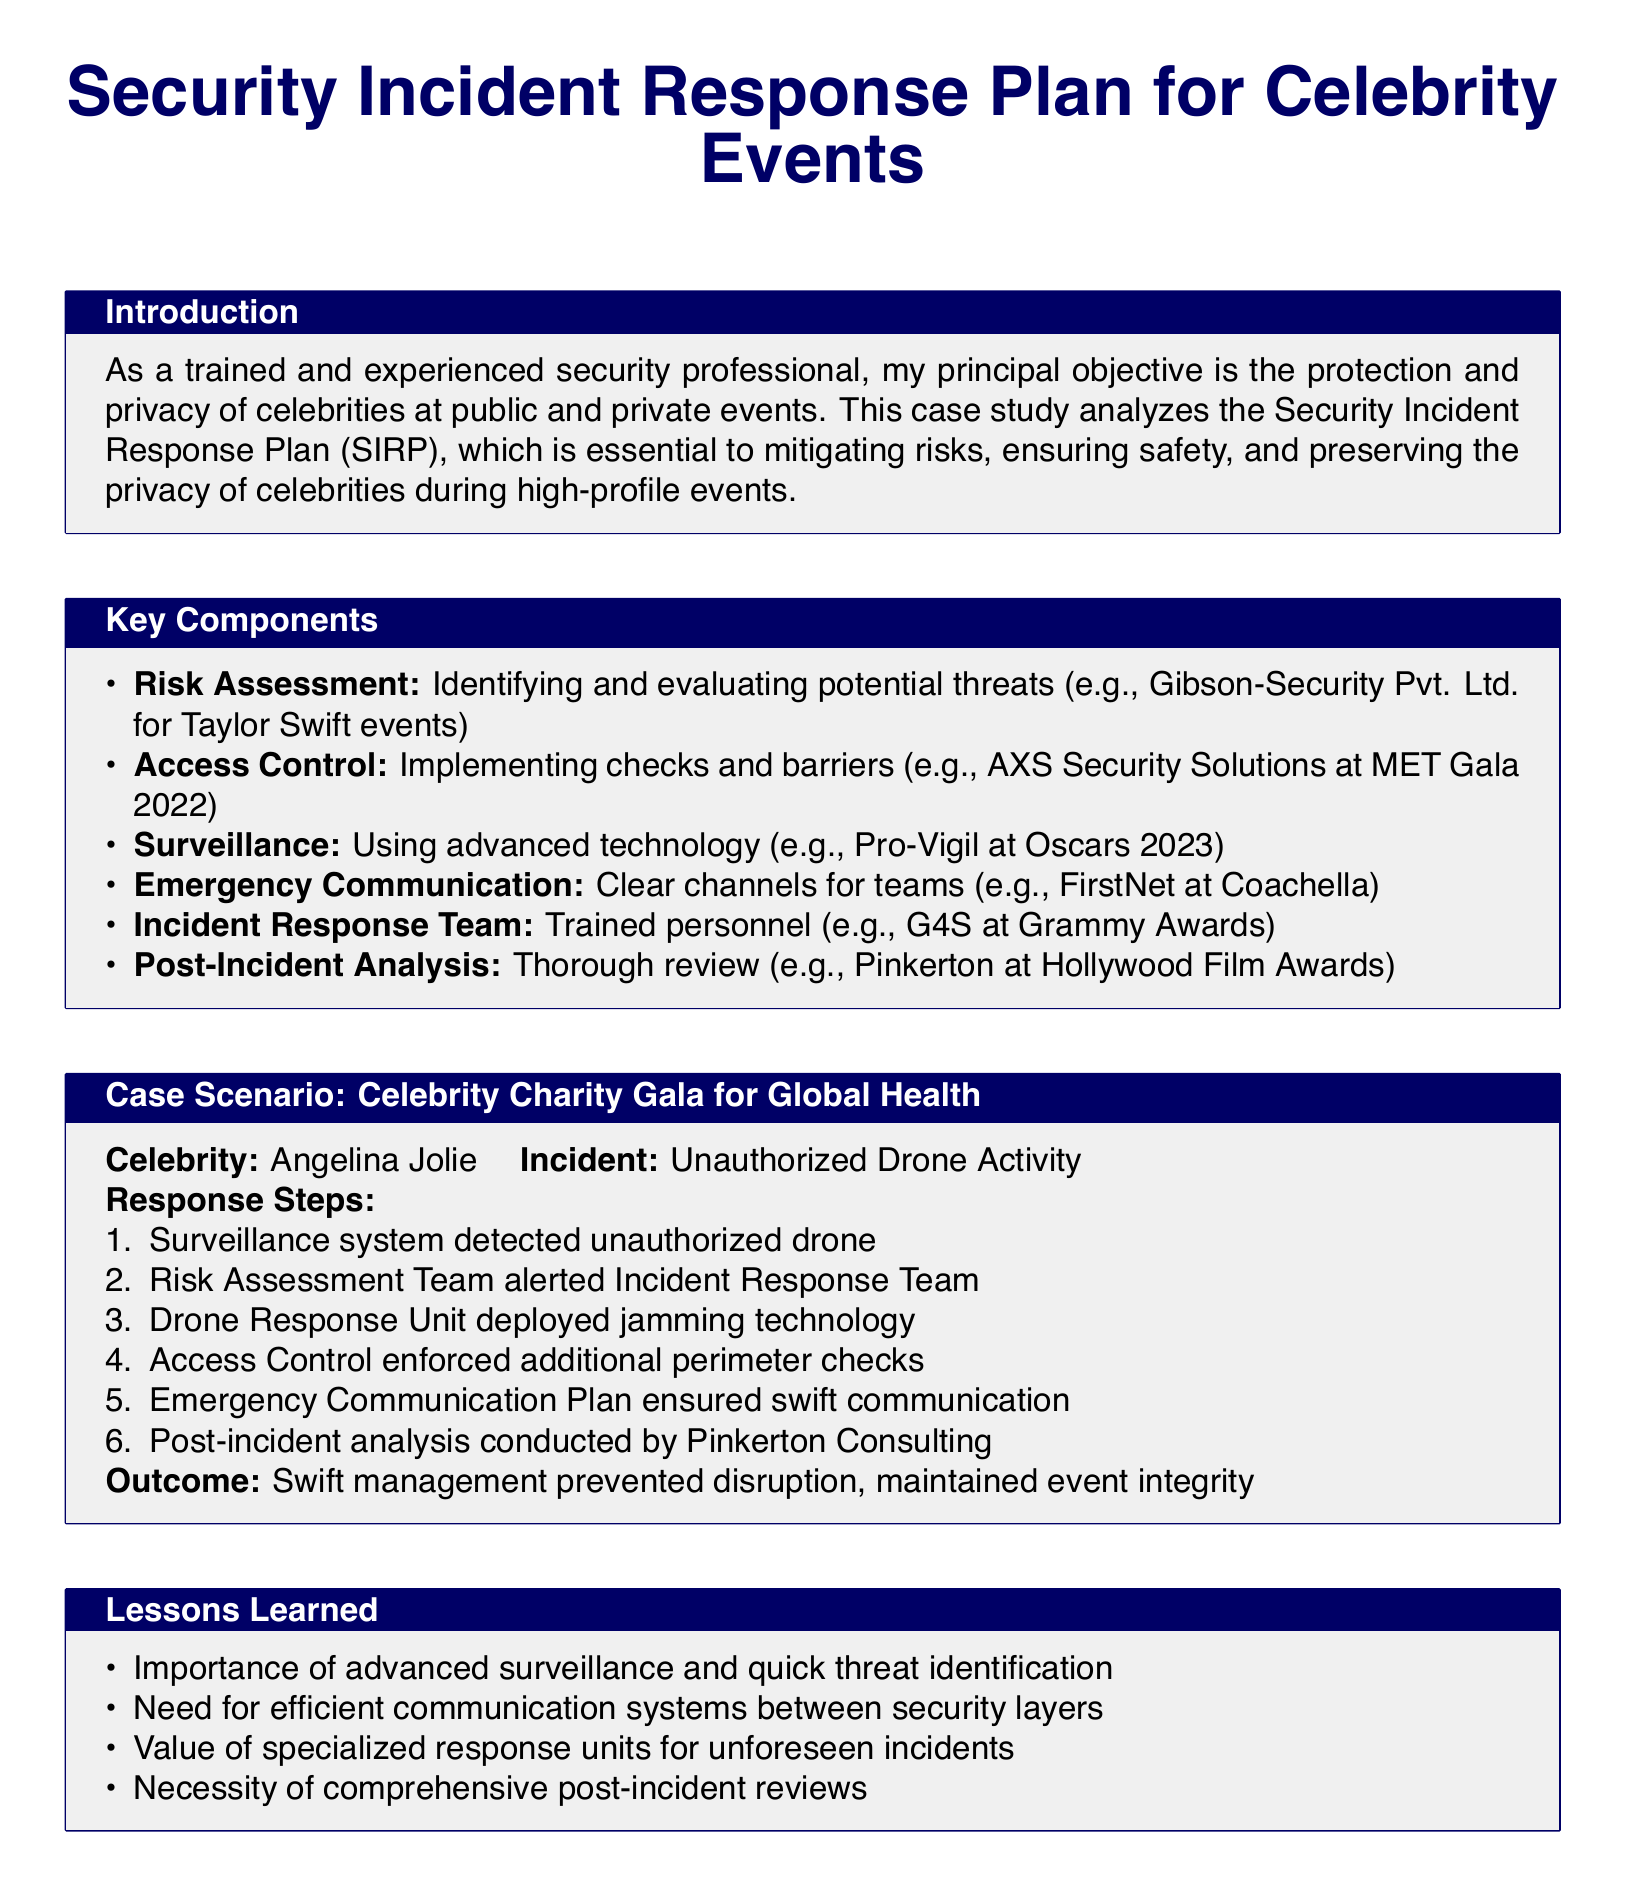What is the primary objective of the security professional? The primary objective is stated as the protection and privacy of celebrities at public and private events.
Answer: Protection and privacy Who was the celebrity involved in the case scenario? The document specifically mentions Angelina Jolie in the case scenario.
Answer: Angelina Jolie What incident occurred at the Celebrity Charity Gala? The incident involved unauthorized drone activity.
Answer: Unauthorized Drone Activity Which company provided surveillance during the Oscars 2023? The document states Pro-Vigil as the surveillance provider at the Oscars 2023.
Answer: Pro-Vigil What technology did the Drone Response Unit deploy? The response step indicates that jamming technology was used by the Drone Response Unit.
Answer: Jamming technology What lesson emphasizes the need for efficient communication? One of the lessons learned addresses the necessity of efficient communication systems between security layers.
Answer: Efficient communication systems How many steps are listed in the incident response for the drone activity? The response steps for the drone activity include a total of six steps.
Answer: Six steps Who conducted the post-incident analysis? The post-incident analysis was conducted by Pinkerton Consulting.
Answer: Pinkerton Consulting What year did the MET Gala take place referenced in the document? The document specifies the MET Gala occurred in the year 2022.
Answer: 2022 